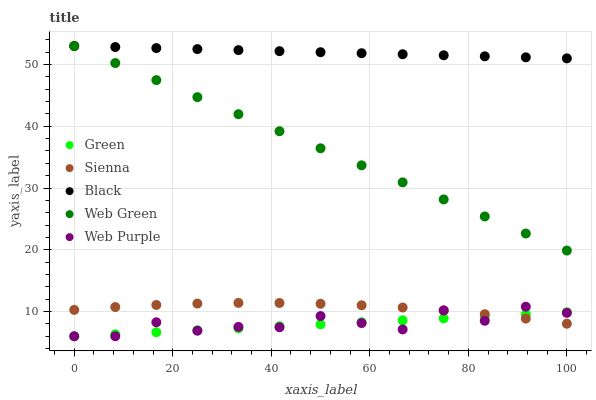Does Green have the minimum area under the curve?
Answer yes or no. Yes. Does Black have the maximum area under the curve?
Answer yes or no. Yes. Does Web Purple have the minimum area under the curve?
Answer yes or no. No. Does Web Purple have the maximum area under the curve?
Answer yes or no. No. Is Green the smoothest?
Answer yes or no. Yes. Is Web Purple the roughest?
Answer yes or no. Yes. Is Black the smoothest?
Answer yes or no. No. Is Black the roughest?
Answer yes or no. No. Does Web Purple have the lowest value?
Answer yes or no. Yes. Does Black have the lowest value?
Answer yes or no. No. Does Web Green have the highest value?
Answer yes or no. Yes. Does Web Purple have the highest value?
Answer yes or no. No. Is Web Purple less than Black?
Answer yes or no. Yes. Is Black greater than Web Purple?
Answer yes or no. Yes. Does Green intersect Sienna?
Answer yes or no. Yes. Is Green less than Sienna?
Answer yes or no. No. Is Green greater than Sienna?
Answer yes or no. No. Does Web Purple intersect Black?
Answer yes or no. No. 